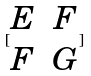Convert formula to latex. <formula><loc_0><loc_0><loc_500><loc_500>[ \begin{matrix} E & F \\ F & G \end{matrix} ]</formula> 